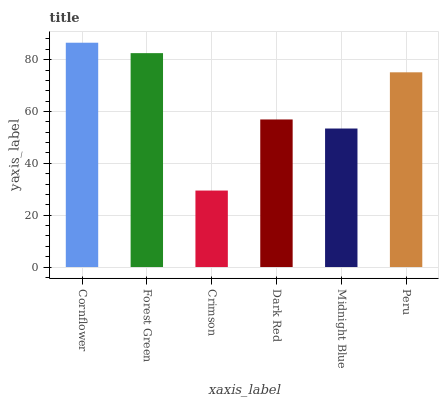Is Crimson the minimum?
Answer yes or no. Yes. Is Cornflower the maximum?
Answer yes or no. Yes. Is Forest Green the minimum?
Answer yes or no. No. Is Forest Green the maximum?
Answer yes or no. No. Is Cornflower greater than Forest Green?
Answer yes or no. Yes. Is Forest Green less than Cornflower?
Answer yes or no. Yes. Is Forest Green greater than Cornflower?
Answer yes or no. No. Is Cornflower less than Forest Green?
Answer yes or no. No. Is Peru the high median?
Answer yes or no. Yes. Is Dark Red the low median?
Answer yes or no. Yes. Is Crimson the high median?
Answer yes or no. No. Is Forest Green the low median?
Answer yes or no. No. 